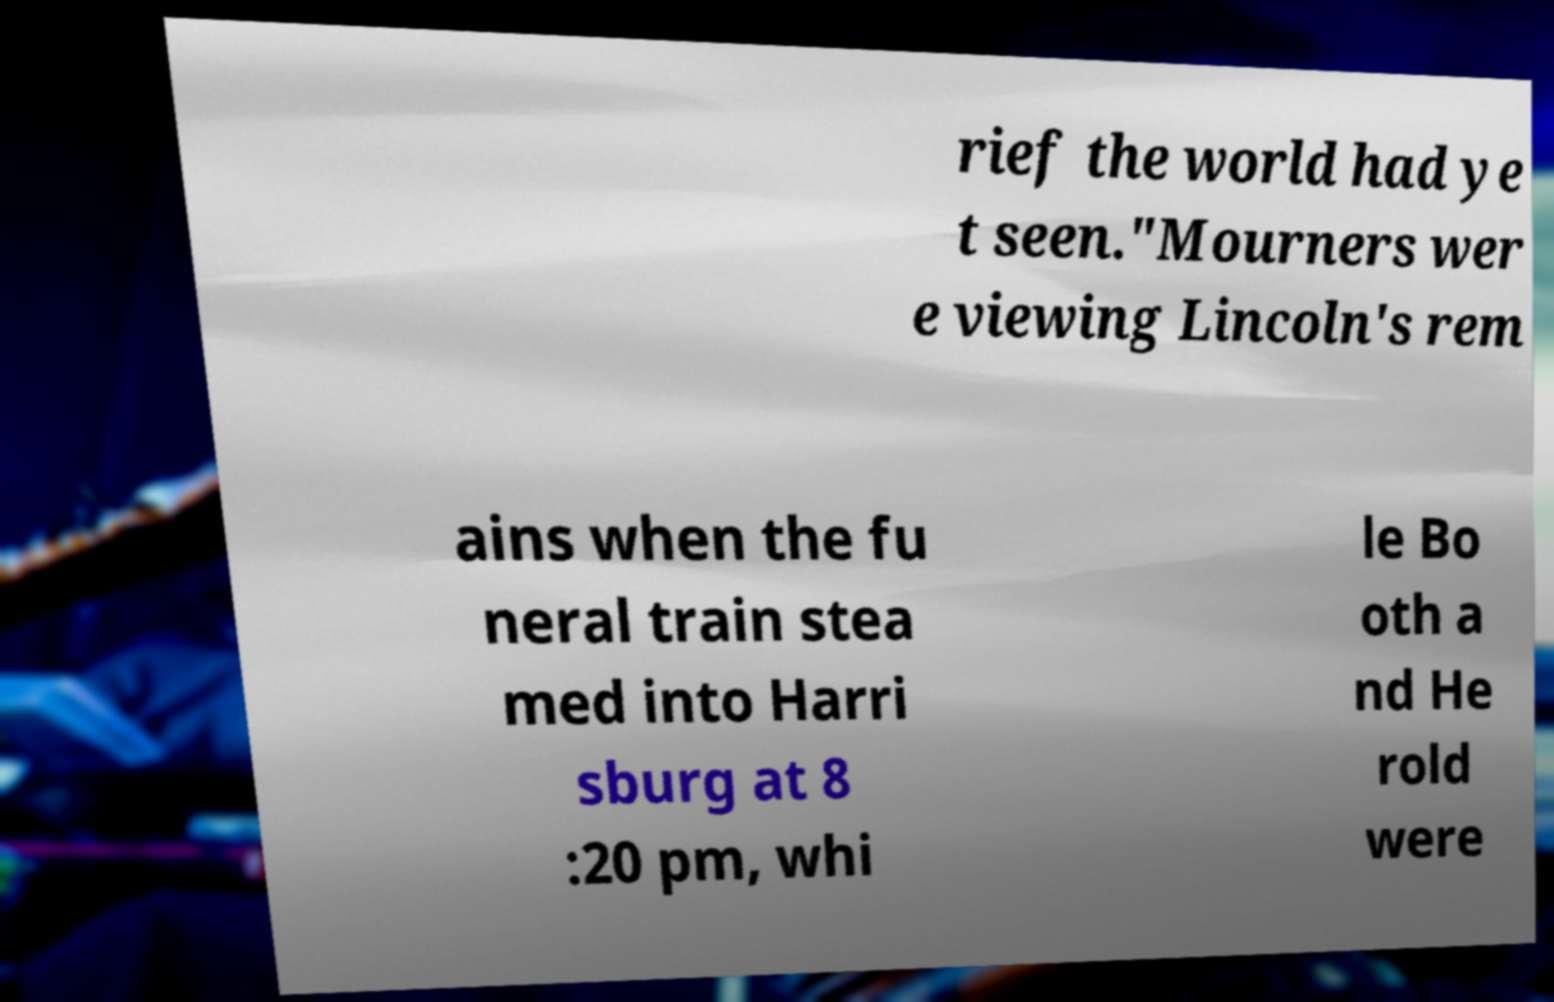For documentation purposes, I need the text within this image transcribed. Could you provide that? rief the world had ye t seen."Mourners wer e viewing Lincoln's rem ains when the fu neral train stea med into Harri sburg at 8 :20 pm, whi le Bo oth a nd He rold were 